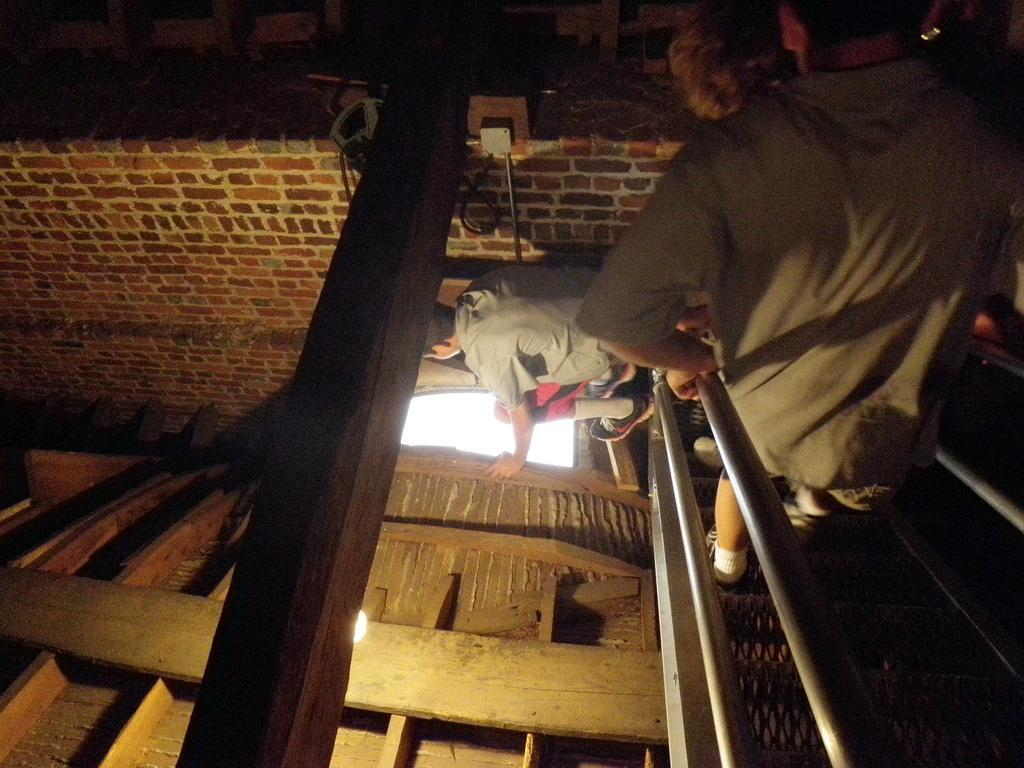Describe this image in one or two sentences. In this image I can see two people and I can see both of them are wearing t shirt and shoes. I can also see light over here and I can see this image is little bit in dark. 